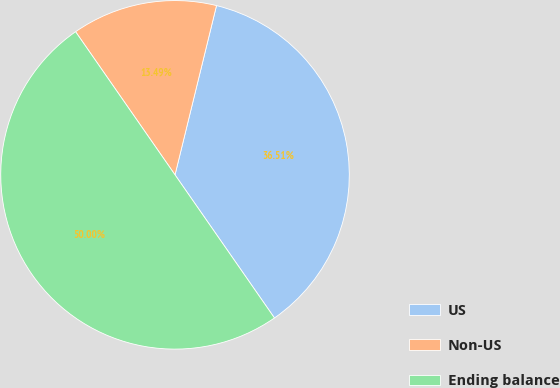Convert chart to OTSL. <chart><loc_0><loc_0><loc_500><loc_500><pie_chart><fcel>US<fcel>Non-US<fcel>Ending balance<nl><fcel>36.51%<fcel>13.49%<fcel>50.0%<nl></chart> 